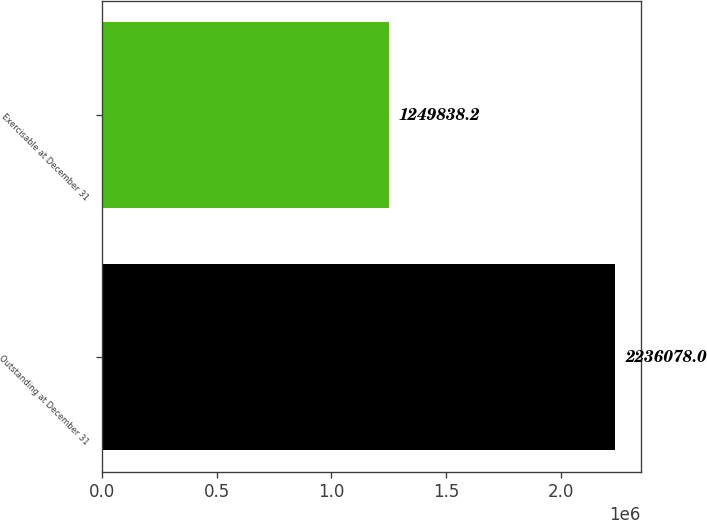Convert chart to OTSL. <chart><loc_0><loc_0><loc_500><loc_500><bar_chart><fcel>Outstanding at December 31<fcel>Exercisable at December 31<nl><fcel>2.23608e+06<fcel>1.24984e+06<nl></chart> 